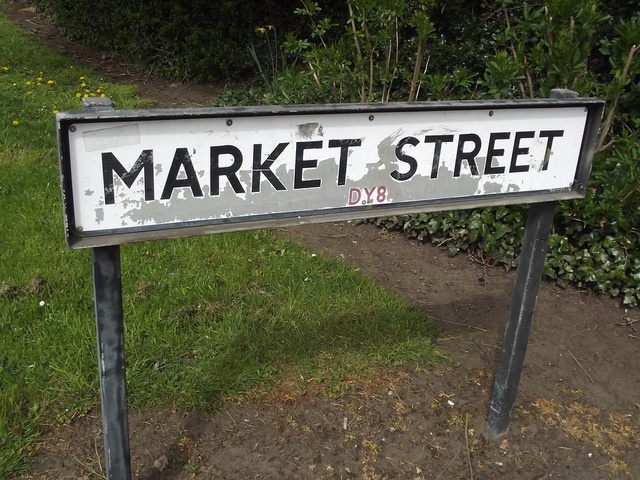Describe the objects in this image and their specific colors. I can see various objects in this image with different colors. 